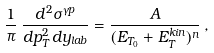<formula> <loc_0><loc_0><loc_500><loc_500>\frac { 1 } { \pi } \, \frac { d ^ { 2 } \sigma ^ { \gamma p } } { d p _ { T } ^ { 2 } \, d y _ { l a b } } = \frac { A } { ( E _ { T _ { 0 } } + E _ { T } ^ { k i n } ) ^ { n } } \, ,</formula> 